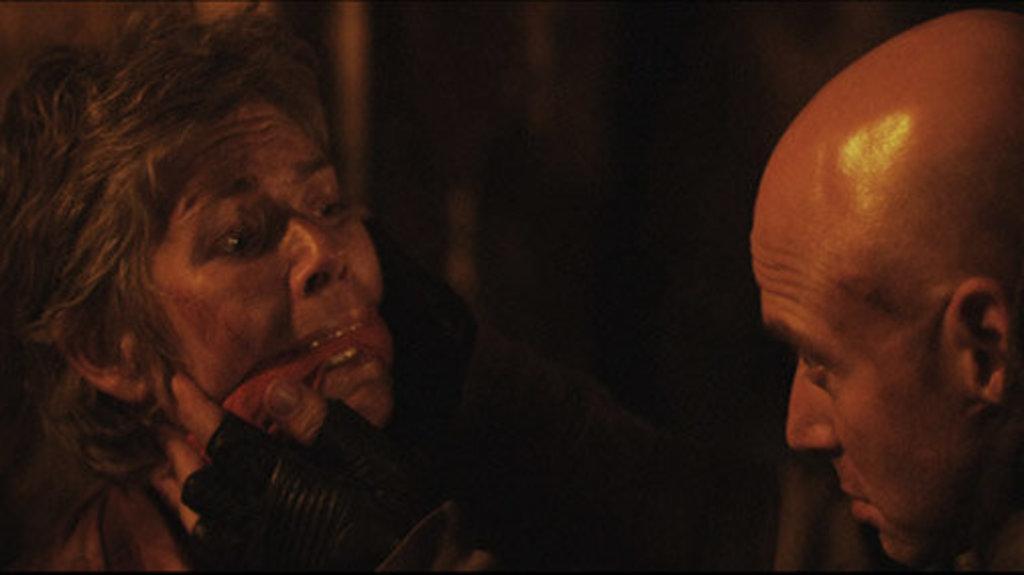Could you give a brief overview of what you see in this image? On the left side, there is a person holding an object with the moth and wearing a black color glove. On the right side, there is a person with bald head. And the background is dark in color. 